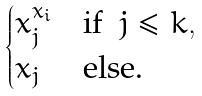Convert formula to latex. <formula><loc_0><loc_0><loc_500><loc_500>\begin{cases} x _ { j } ^ { x _ { i } } & \text {if } \ j \leq k , \\ x _ { j } & \text {else.} \end{cases}</formula> 